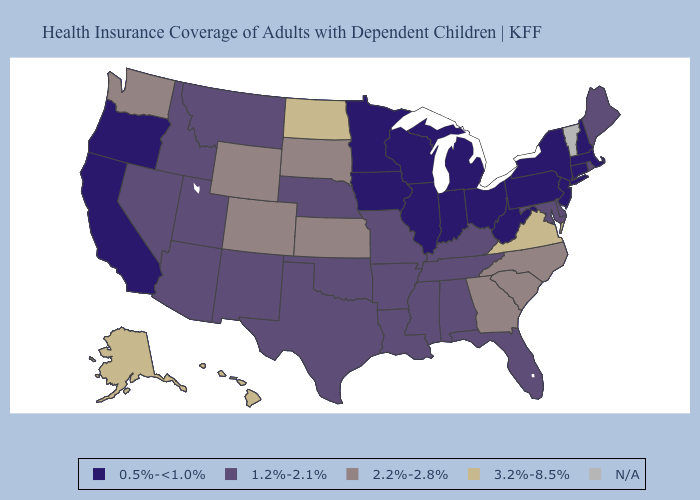Name the states that have a value in the range 2.2%-2.8%?
Short answer required. Colorado, Georgia, Kansas, North Carolina, South Carolina, South Dakota, Washington, Wyoming. Does Missouri have the lowest value in the MidWest?
Short answer required. No. Name the states that have a value in the range 2.2%-2.8%?
Keep it brief. Colorado, Georgia, Kansas, North Carolina, South Carolina, South Dakota, Washington, Wyoming. What is the value of Indiana?
Concise answer only. 0.5%-<1.0%. What is the value of Nevada?
Be succinct. 1.2%-2.1%. Name the states that have a value in the range 2.2%-2.8%?
Give a very brief answer. Colorado, Georgia, Kansas, North Carolina, South Carolina, South Dakota, Washington, Wyoming. Name the states that have a value in the range 1.2%-2.1%?
Quick response, please. Alabama, Arizona, Arkansas, Delaware, Florida, Idaho, Kentucky, Louisiana, Maine, Maryland, Mississippi, Missouri, Montana, Nebraska, Nevada, New Mexico, Oklahoma, Rhode Island, Tennessee, Texas, Utah. What is the value of South Carolina?
Concise answer only. 2.2%-2.8%. How many symbols are there in the legend?
Short answer required. 5. What is the value of Missouri?
Give a very brief answer. 1.2%-2.1%. Name the states that have a value in the range 1.2%-2.1%?
Be succinct. Alabama, Arizona, Arkansas, Delaware, Florida, Idaho, Kentucky, Louisiana, Maine, Maryland, Mississippi, Missouri, Montana, Nebraska, Nevada, New Mexico, Oklahoma, Rhode Island, Tennessee, Texas, Utah. Does Indiana have the lowest value in the USA?
Concise answer only. Yes. What is the lowest value in the USA?
Short answer required. 0.5%-<1.0%. Does the map have missing data?
Short answer required. Yes. 